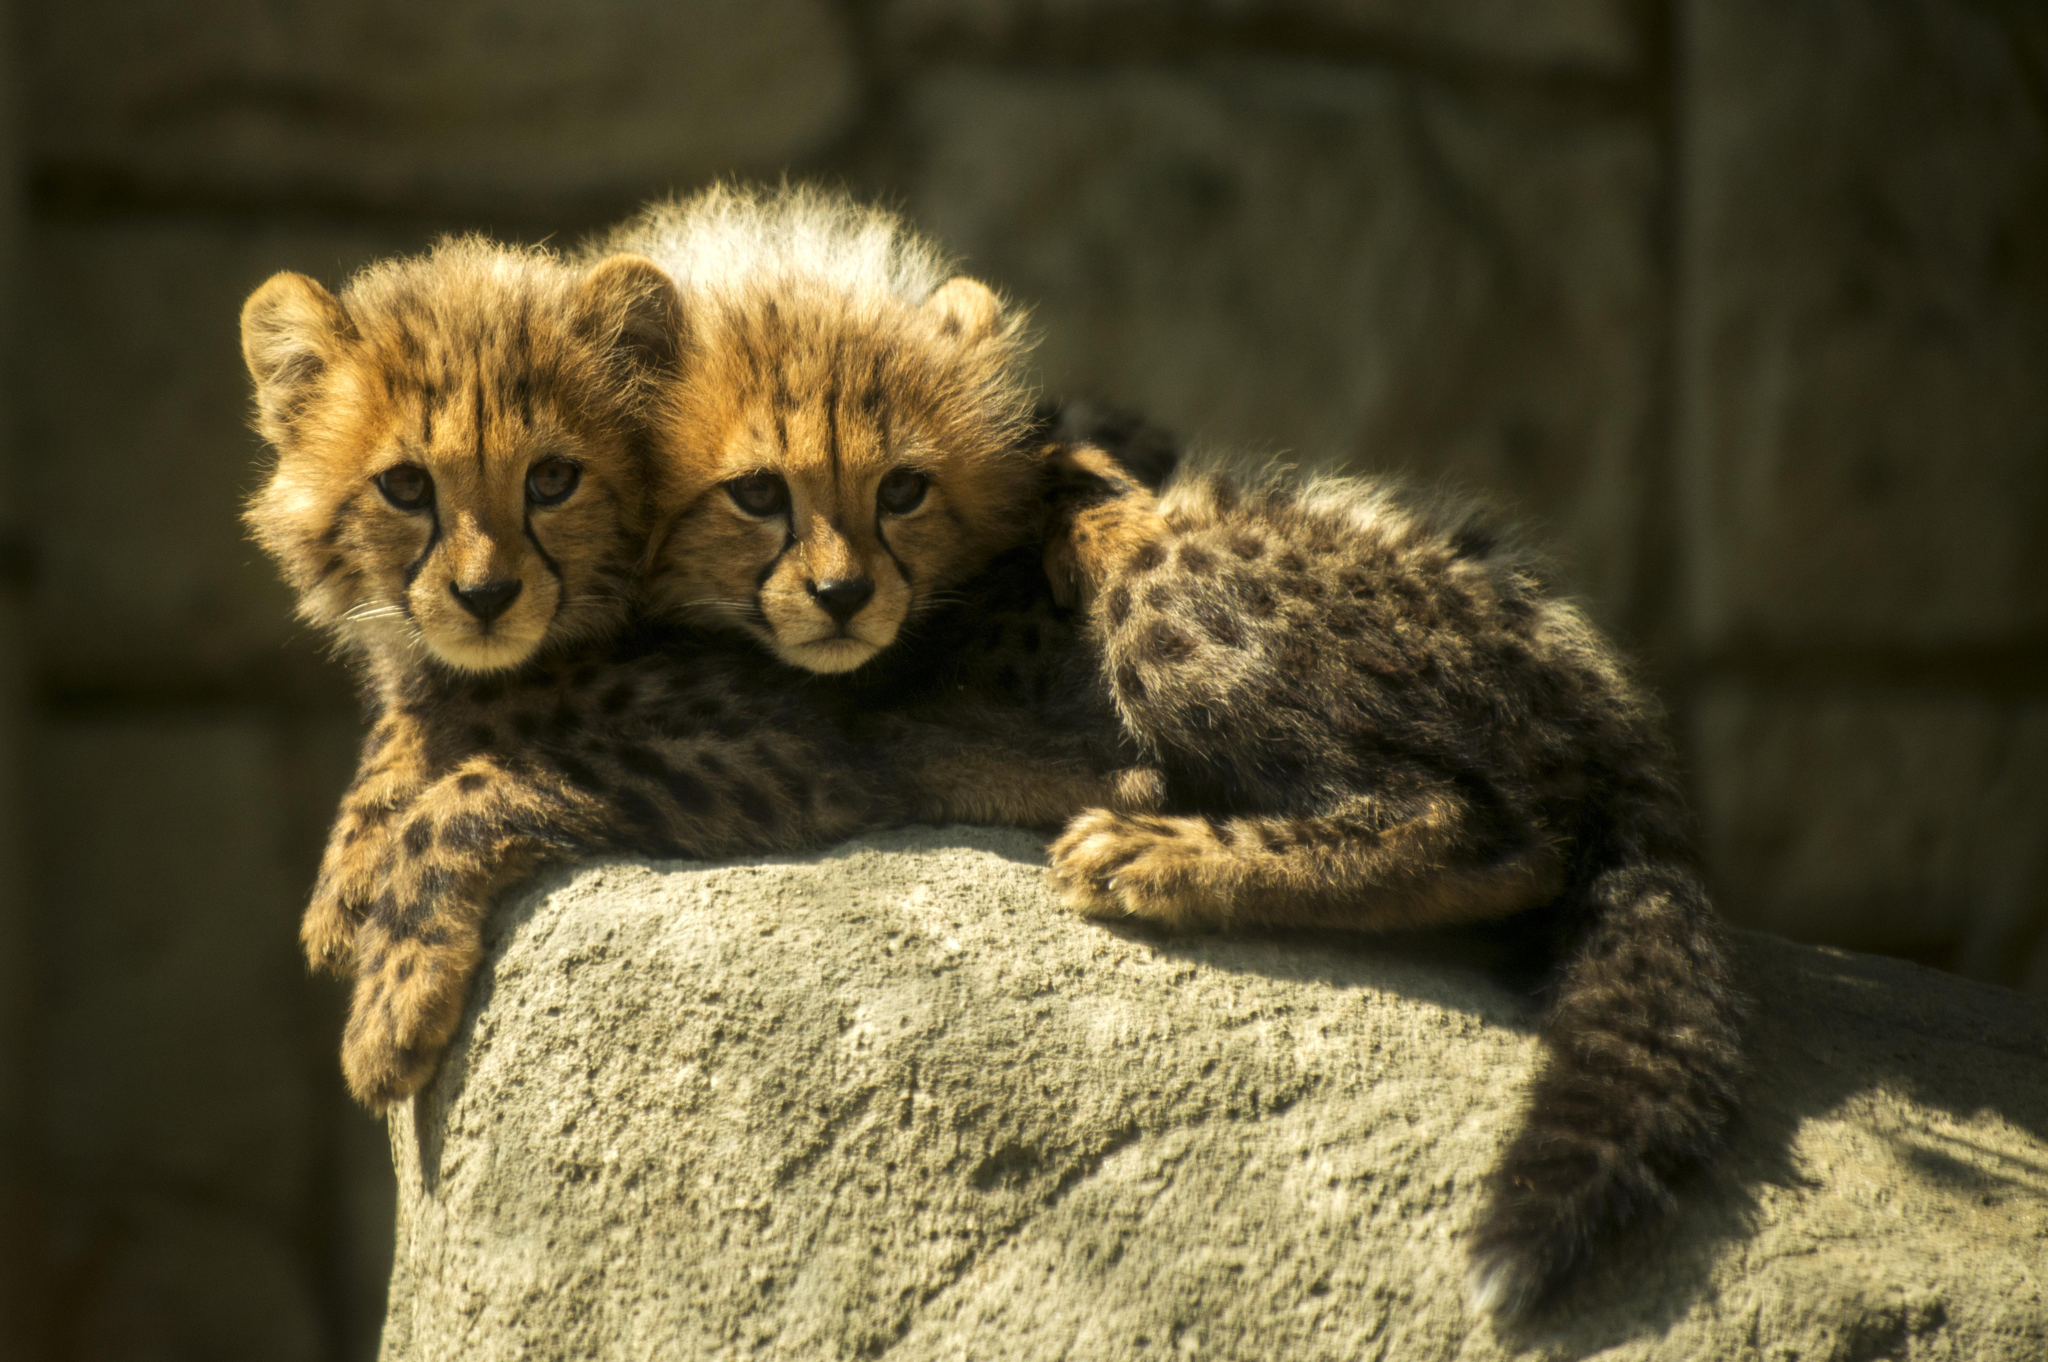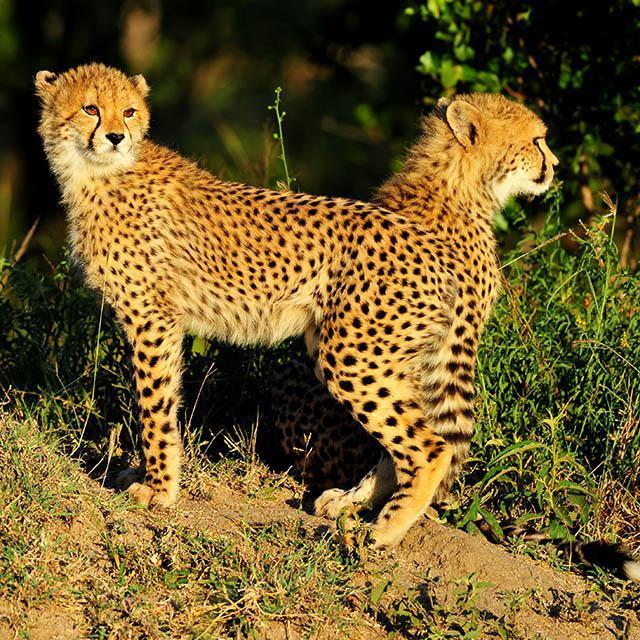The first image is the image on the left, the second image is the image on the right. Given the left and right images, does the statement "Each image shows exactly one pair of wild spotted cts with their heads overlapping." hold true? Answer yes or no. No. 